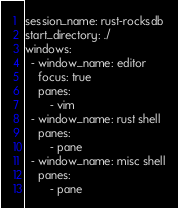<code> <loc_0><loc_0><loc_500><loc_500><_YAML_>session_name: rust-rocksdb
start_directory: ./
windows:
  - window_name: editor
    focus: true
    panes:
        - vim
  - window_name: rust shell
    panes:
        - pane
  - window_name: misc shell
    panes:
        - pane
</code> 